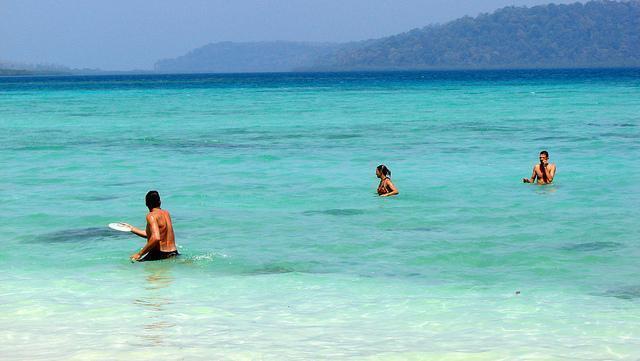What is the man in deep water about to catch?
Indicate the correct choice and explain in the format: 'Answer: answer
Rationale: rationale.'
Options: Frisbee, cold, whale, dolphin ride. Answer: frisbee.
Rationale: The other man is getting ready to throw him a frisbee. 